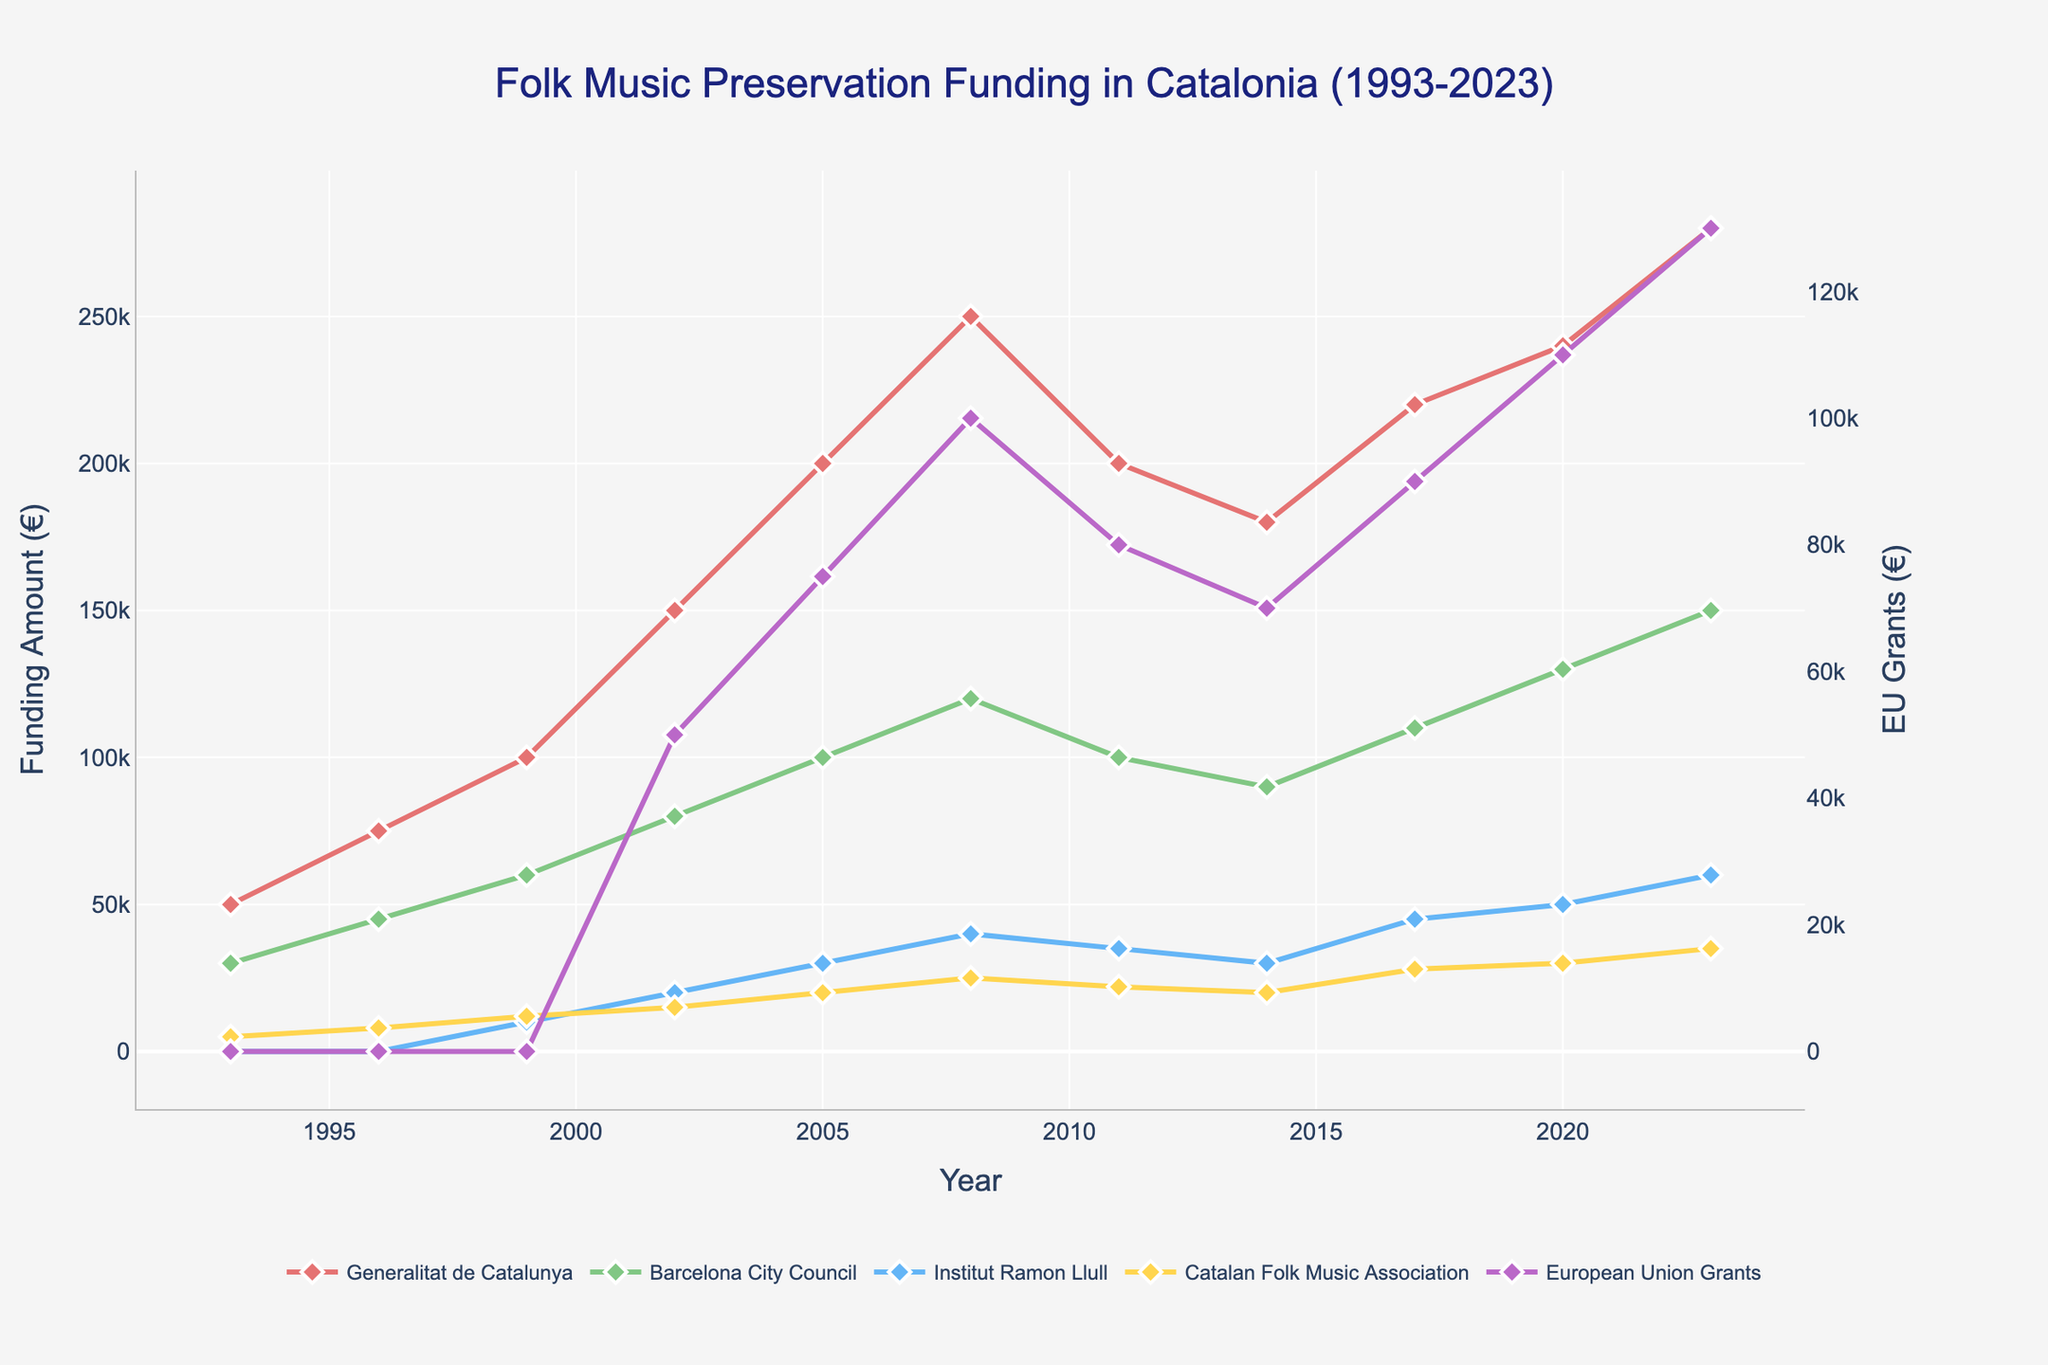What is the trend of funding from the Generalitat de Catalunya over the past three decades? The funding from the Generalitat de Catalunya shows a general upward trend. It starts at €50,000 in 1993 and increases to €280,000 by 2023, with some fluctuations.
Answer: Increasing Which organization received the highest funding in 2008? In 2008, the Generalitat de Catalunya received the highest funding of €250,000.
Answer: Generalitat de Catalunya How does the funding from the Barcelona City Council in 2020 compare to its funding in 2008? The funding from the Barcelona City Council increased from €120,000 in 2008 to €130,000 in 2020.
Answer: Increased How much total funding was allocated for folk music preservation projects in 2023? The total funding in 2023 is the sum of all contributions: €280,000 (Generalitat de Catalunya) + €150,000 (Barcelona City Council) + €60,000 (Institut Ramon Llull) + €35,000 (Catalan Folk Music Association) + €130,000 (European Union Grants) = €655,000.
Answer: €655,000 What is the average funding provided by the Institut Ramon Llull between 1999 and 2023? The funding amounts are €10,000 (1999), €20,000 (2002), €30,000 (2005), €40,000 (2008), €35,000 (2011), €30,000 (2014), €45,000 (2017), €50,000 (2020), €60,000 (2023). The average is calculated as sum of these amounts divided by the number of years: (10,000 + 20,000 + 30,000 + 40,000 + 35,000 + 30,000 + 45,000 + 50,000 + 60,000) / 9 = 35,555.56.
Answer: €35,555.56 Which line is represented by a purple color in the figure? The purple color represents the European Union Grants in the figure.
Answer: European Union Grants In what year did the Catalan Folk Music Association's funding first reach €20,000? The Catalan Folk Music Association's funding first reached €20,000 in the year 2005.
Answer: 2005 What was the biggest drop in funding for the Institut Ramon Llull between consecutive years? The biggest drop for the Institut Ramon Llull occurred from 2008 to 2011, where the funding decreased from €40,000 to €35,000, a total drop of €5,000.
Answer: €5,000 